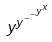Convert formula to latex. <formula><loc_0><loc_0><loc_500><loc_500>y ^ { y ^ { - ^ { - ^ { y ^ { x } } } } }</formula> 